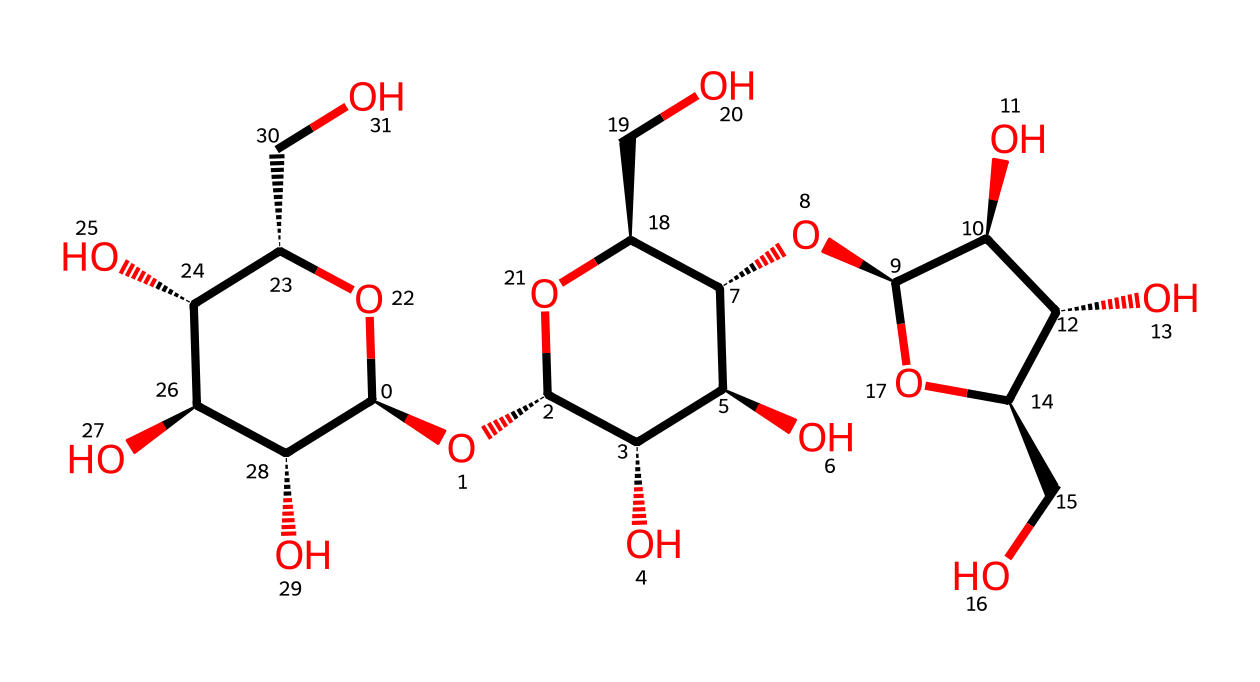What is the primary type of polymer in this chemical structure? The presence of hydroxyl (-OH) functional groups and its repeating glucose units indicates that this chemical is a polysaccharide, specifically cellulose, which is a natural polymer commonly found in cotton fibers.
Answer: polysaccharide How many carbon atoms are present in the molecular structure? By analyzing the SMILES notation and counting the number of carbon (C) atoms represented, one can derive that there are a total of 12 carbon atoms in the structure.
Answer: 12 What functional groups are present in this chemical? The structure contains multiple hydroxyl (-OH) functional groups, which are indicative of its ability to form hydrogen bonds, a key property in fibers like cotton that leads to absorbency.
Answer: hydroxyl groups What is the main application of this chemical in the context of military uniforms? This chemical, being cellulose, contributes to the durability and comfort of cotton fibers used in military uniforms, providing good moisture management and breathability.
Answer: military uniforms How does the molecular structure of this fiber influence its tensile strength? The extensive hydrogen bonding capability due to the multiple hydroxyl groups enhances intermolecular forces, resulting in greater tensile strength, which is crucial for the enduring performance of fibers under stress.
Answer: tensile strength How many hydroxyl groups are present in this structure? By examining the repeating units within the SMILES representation, it can be noted that there are eight hydroxyl groups dispersed throughout the entire molecular structure.
Answer: eight 